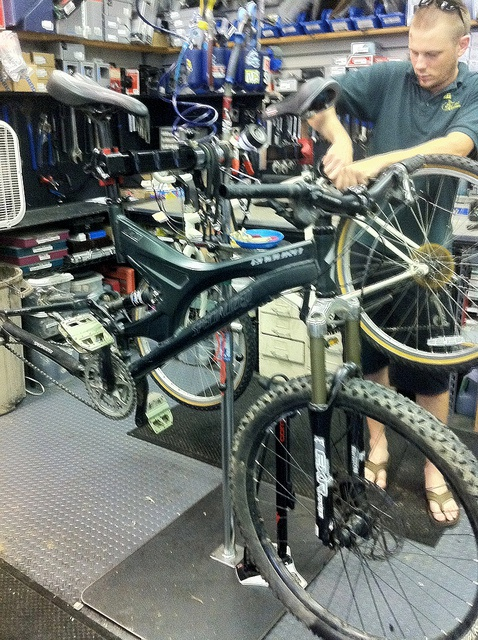Describe the objects in this image and their specific colors. I can see bicycle in salmon, black, gray, darkgray, and beige tones, bicycle in salmon, black, gray, darkgray, and ivory tones, and people in salmon, gray, tan, beige, and darkgray tones in this image. 